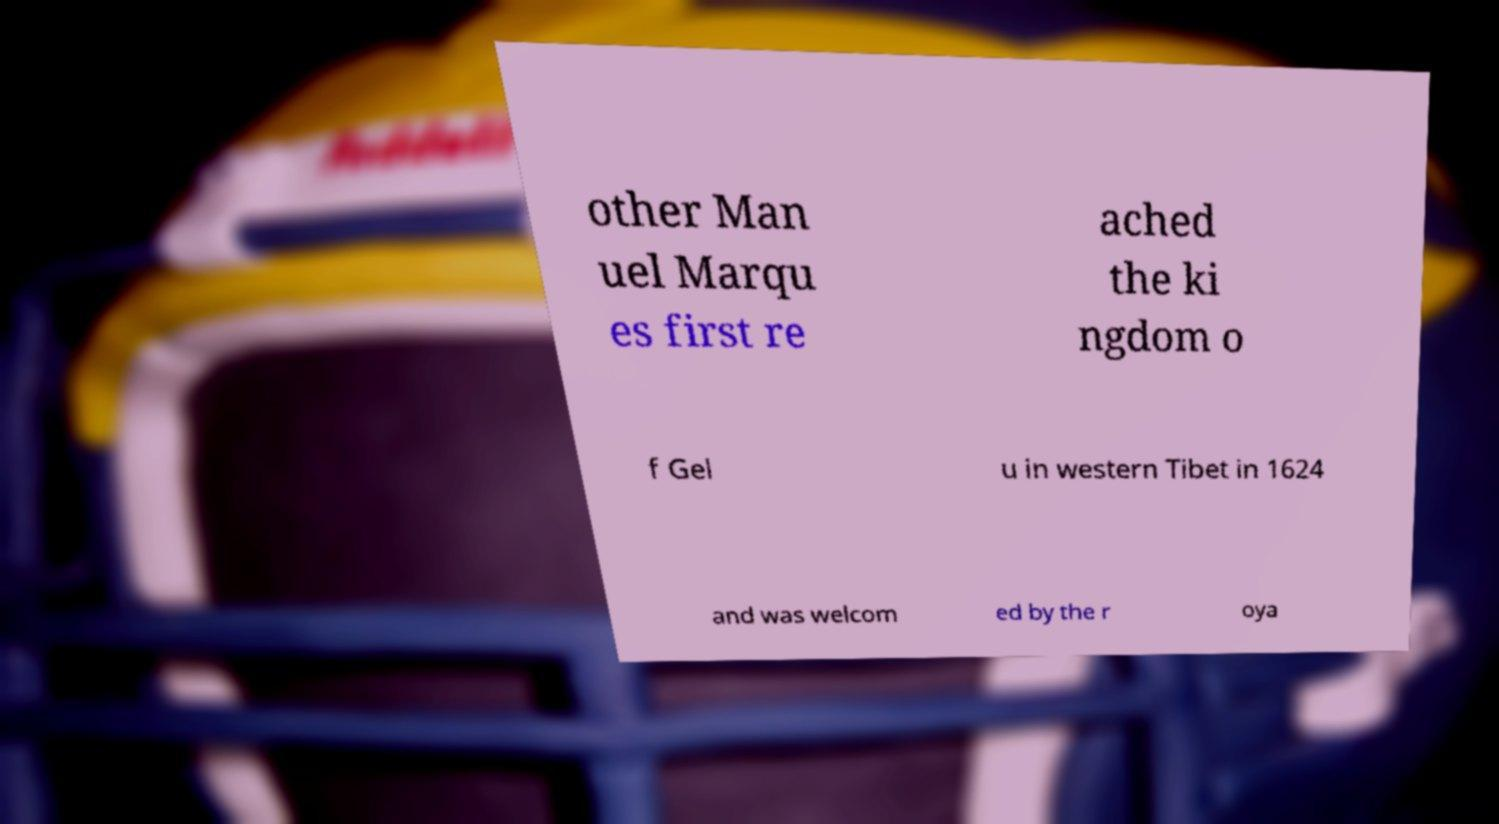Please identify and transcribe the text found in this image. other Man uel Marqu es first re ached the ki ngdom o f Gel u in western Tibet in 1624 and was welcom ed by the r oya 